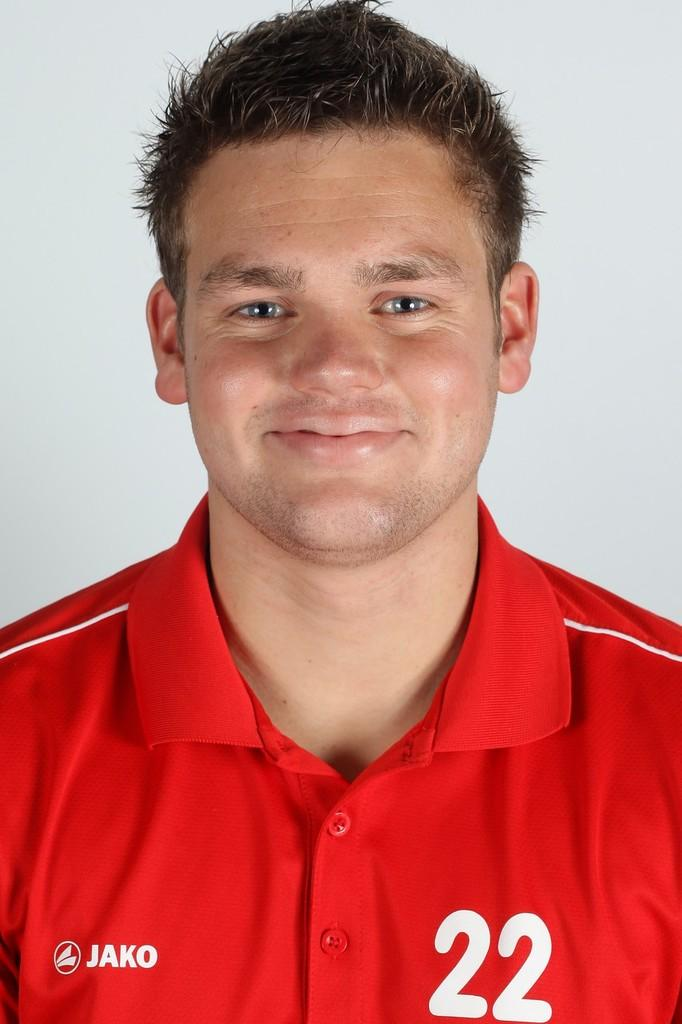<image>
Offer a succinct explanation of the picture presented. A man smiles for the camera wearing a red top with the number 22 on it and a JAKO logo 